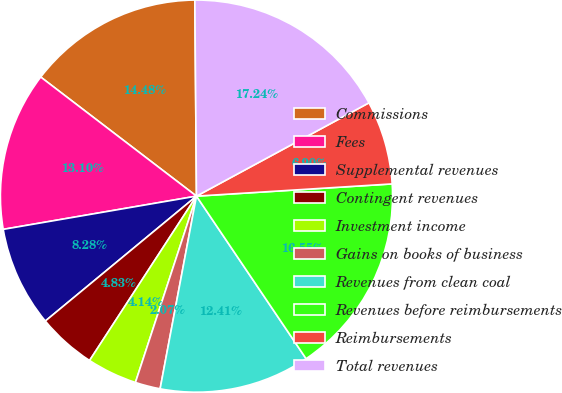<chart> <loc_0><loc_0><loc_500><loc_500><pie_chart><fcel>Commissions<fcel>Fees<fcel>Supplemental revenues<fcel>Contingent revenues<fcel>Investment income<fcel>Gains on books of business<fcel>Revenues from clean coal<fcel>Revenues before reimbursements<fcel>Reimbursements<fcel>Total revenues<nl><fcel>14.48%<fcel>13.1%<fcel>8.28%<fcel>4.83%<fcel>4.14%<fcel>2.07%<fcel>12.41%<fcel>16.55%<fcel>6.9%<fcel>17.24%<nl></chart> 